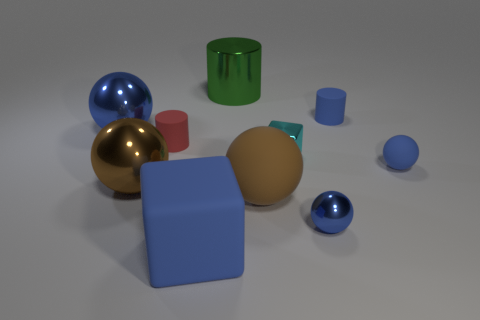Subtract all blue rubber cylinders. How many cylinders are left? 2 Subtract all red cylinders. How many cylinders are left? 2 Subtract 2 cubes. How many cubes are left? 0 Add 8 large blue blocks. How many large blue blocks are left? 9 Add 9 big gray rubber blocks. How many big gray rubber blocks exist? 9 Subtract 2 brown spheres. How many objects are left? 8 Subtract all cubes. How many objects are left? 8 Subtract all red blocks. Subtract all purple balls. How many blocks are left? 2 Subtract all purple cubes. How many blue balls are left? 3 Subtract all large blue metal spheres. Subtract all tiny red things. How many objects are left? 8 